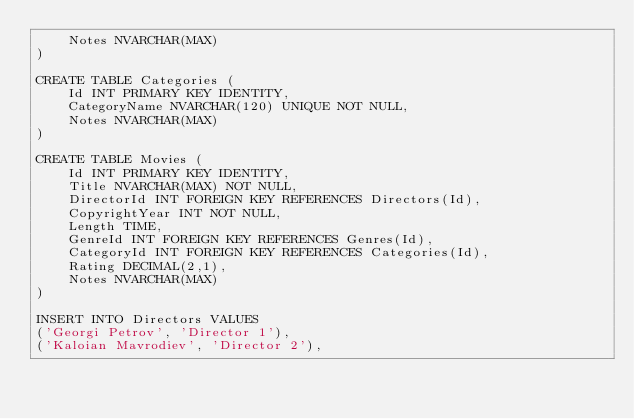Convert code to text. <code><loc_0><loc_0><loc_500><loc_500><_SQL_>	Notes NVARCHAR(MAX)
)

CREATE TABLE Categories (
	Id INT PRIMARY KEY IDENTITY,
	CategoryName NVARCHAR(120) UNIQUE NOT NULL,
	Notes NVARCHAR(MAX)
)

CREATE TABLE Movies (
	Id INT PRIMARY KEY IDENTITY,
	Title NVARCHAR(MAX) NOT NULL,
	DirectorId INT FOREIGN KEY REFERENCES Directors(Id),
	CopyrightYear INT NOT NULL,
	Length TIME,
	GenreId INT FOREIGN KEY REFERENCES Genres(Id),
	CategoryId INT FOREIGN KEY REFERENCES Categories(Id),
	Rating DECIMAL(2,1),
	Notes NVARCHAR(MAX)
)

INSERT INTO Directors VALUES
('Georgi Petrov', 'Director 1'),
('Kaloian Mavrodiev', 'Director 2'),</code> 